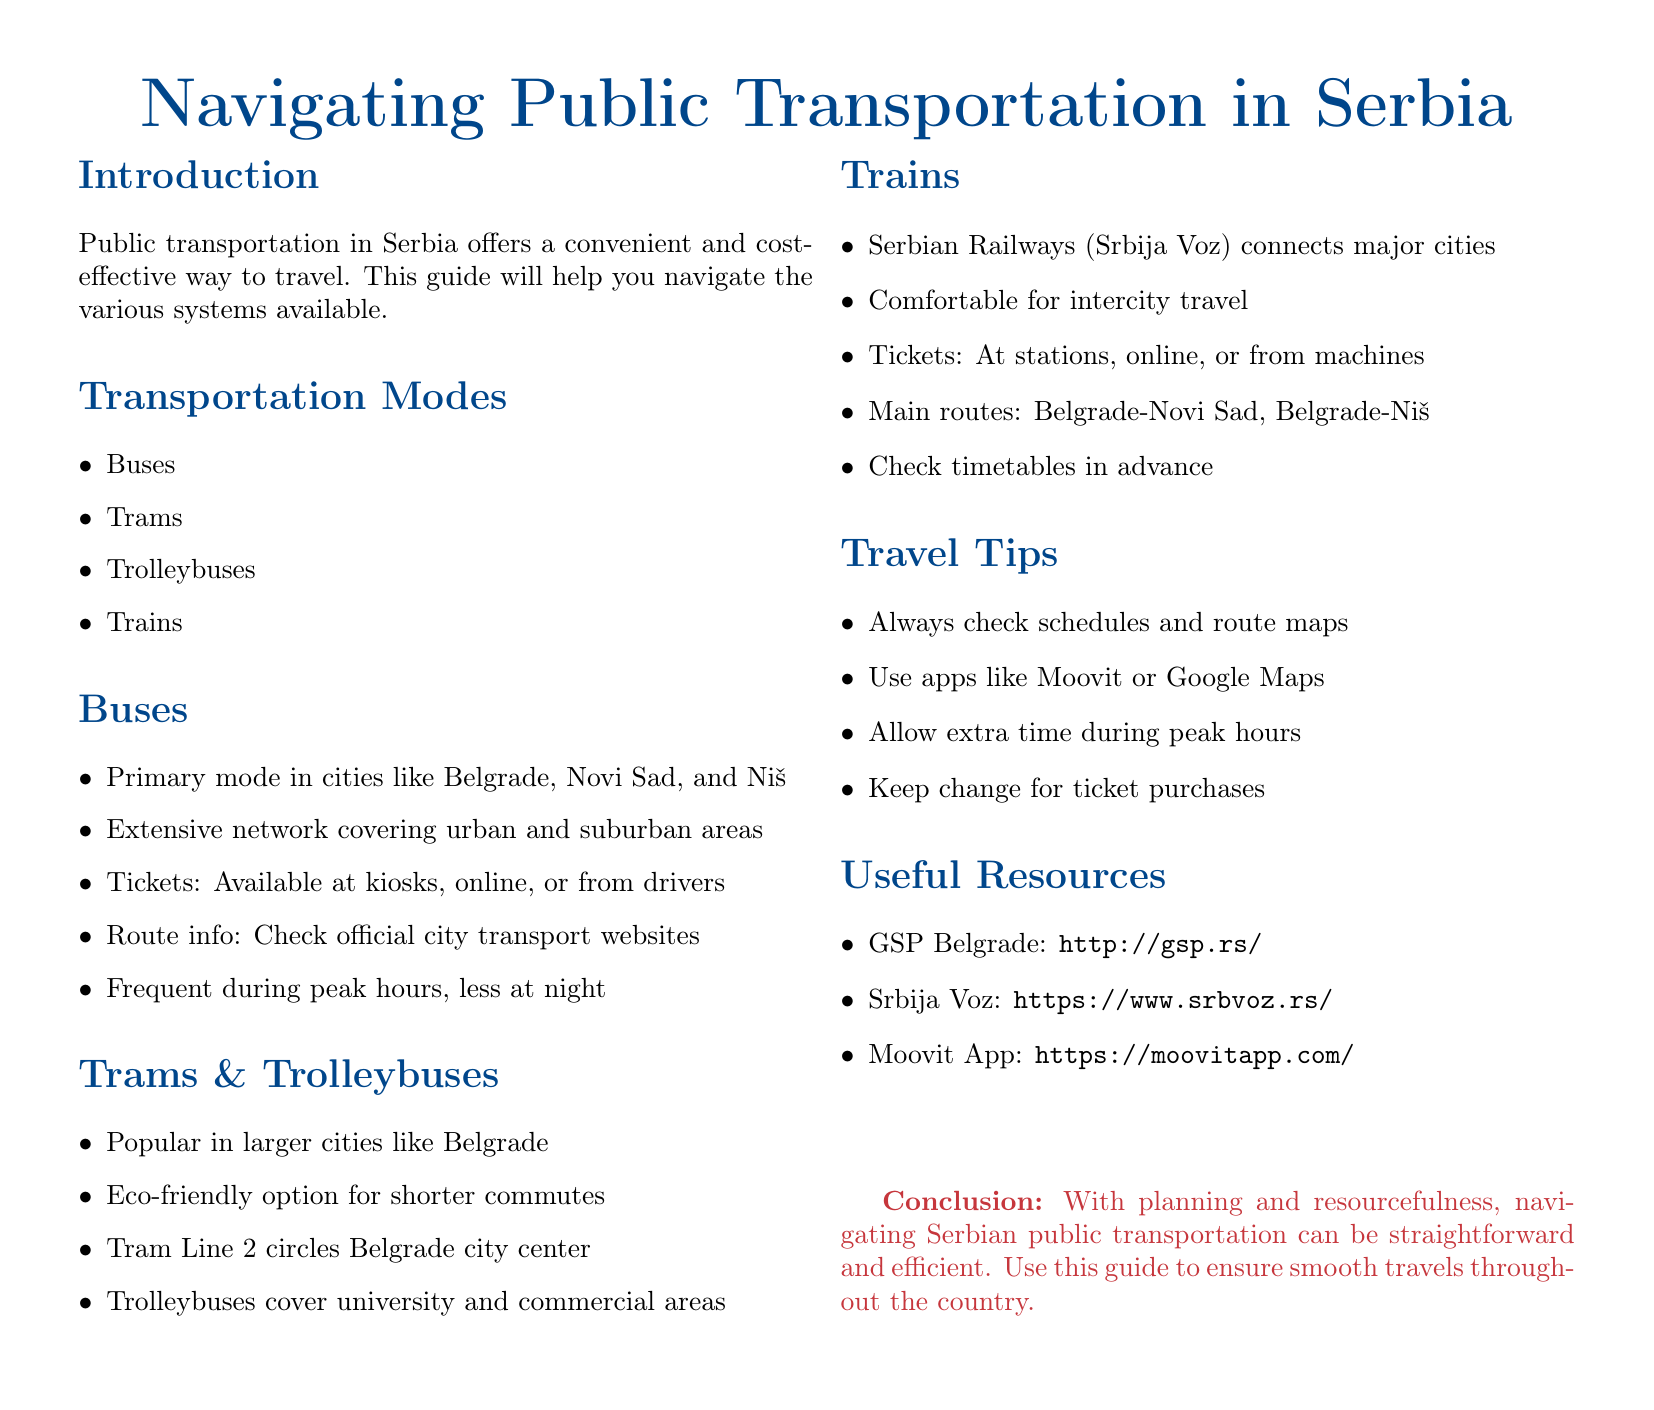What are the types of public transportation in Serbia? The document lists different modes of public transportation in Serbia, which include buses, trams, trolleybuses, and trains.
Answer: Buses, trams, trolleybuses, trains Which public transportation mode is primary in cities like Belgrade? The document specifies that buses are the primary mode of transportation in cities such as Belgrade, Novi Sad, and Niš.
Answer: Buses Where can you buy tickets for trains? The document states that train tickets can be purchased at stations, online, or from machines.
Answer: At stations, online, or from machines What is one eco-friendly transportation option mentioned? The guide mentions trams and trolleybuses as popular and eco-friendly options for shorter commutes in larger cities.
Answer: Trams and trolleybuses What is a useful app for navigating public transport? The document provides a suggestion for an app that helps with public transport navigation in Serbia.
Answer: Moovit How frequently do buses operate during peak hours? According to the document, buses are frequent during peak hours, but the frequency decreases at night.
Answer: Frequent What should travelers do during peak hours? The travel tips section advises travelers to allow extra time during peak hours.
Answer: Allow extra time What is the website for GSP Belgrade? The document provides the URL for GSP Belgrade as a useful resource for public transportation information.
Answer: http://gsp.rs/ What is the conclusion of the guide? The conclusion emphasizes that with planning and resourcefulness, navigating public transportation in Serbia can be manageable.
Answer: Navigating Serbian public transportation can be straightforward and efficient 